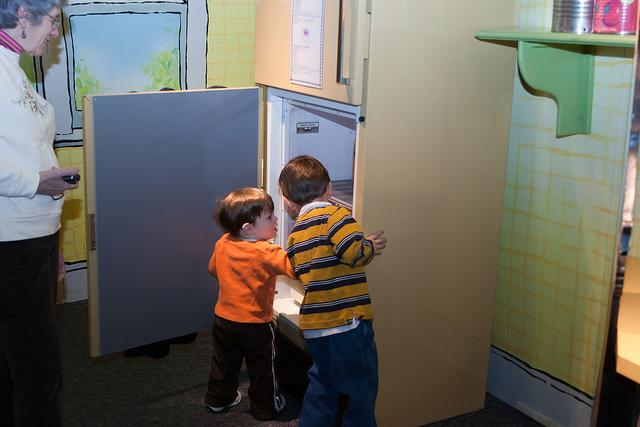The wall decoration and props here are modeled after which location?

Choices:
A) garage
B) living room
C) bedroom
D) kitchen kitchen 